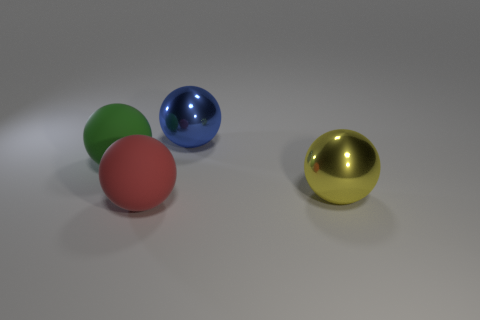Are there any other things that have the same material as the big green ball?
Your answer should be very brief. Yes. There is a yellow thing that is the same shape as the large red matte thing; what is its size?
Give a very brief answer. Large. Are there any big red rubber things behind the big red rubber object?
Ensure brevity in your answer.  No. Are there an equal number of yellow shiny things to the left of the large red matte sphere and big red shiny blocks?
Ensure brevity in your answer.  Yes. There is a big shiny sphere behind the big ball on the left side of the red thing; are there any green matte balls right of it?
Make the answer very short. No. What is the large blue object made of?
Ensure brevity in your answer.  Metal. How many other things are the same shape as the big red object?
Your response must be concise. 3. Is the shape of the green rubber object the same as the big red rubber thing?
Your answer should be very brief. Yes. How many objects are balls to the left of the yellow ball or big metal objects that are behind the large green rubber thing?
Your response must be concise. 3. What number of objects are either large shiny things or big yellow cubes?
Provide a succinct answer. 2. 